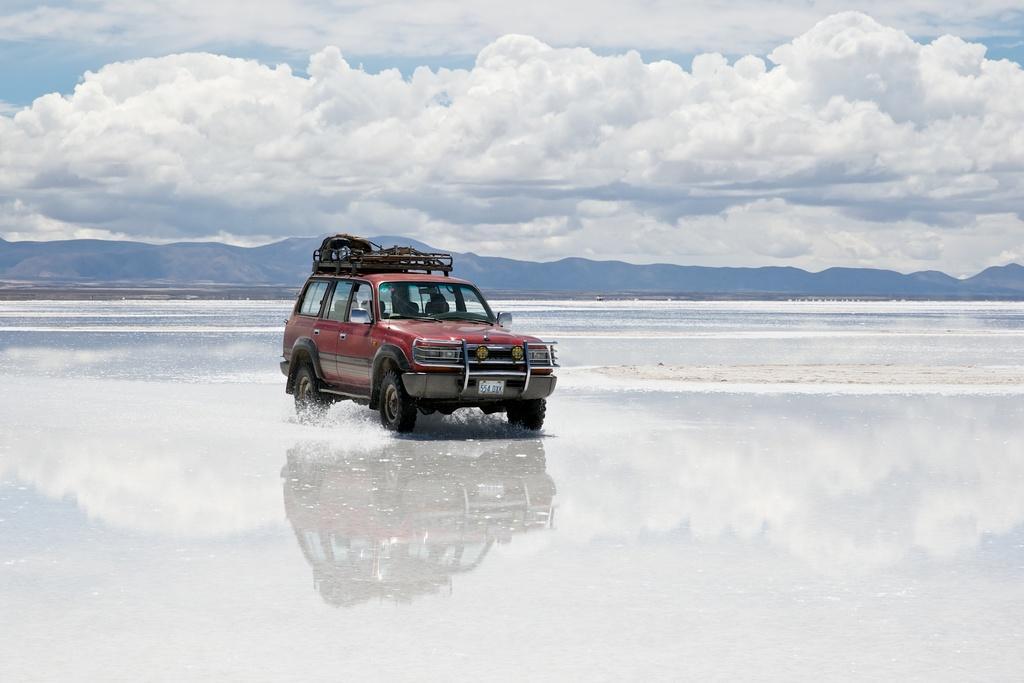How would you summarize this image in a sentence or two? In this picture I can see the water and in the middle of this picture I can see a red color car. In the background I can see the sky which is cloudy. 